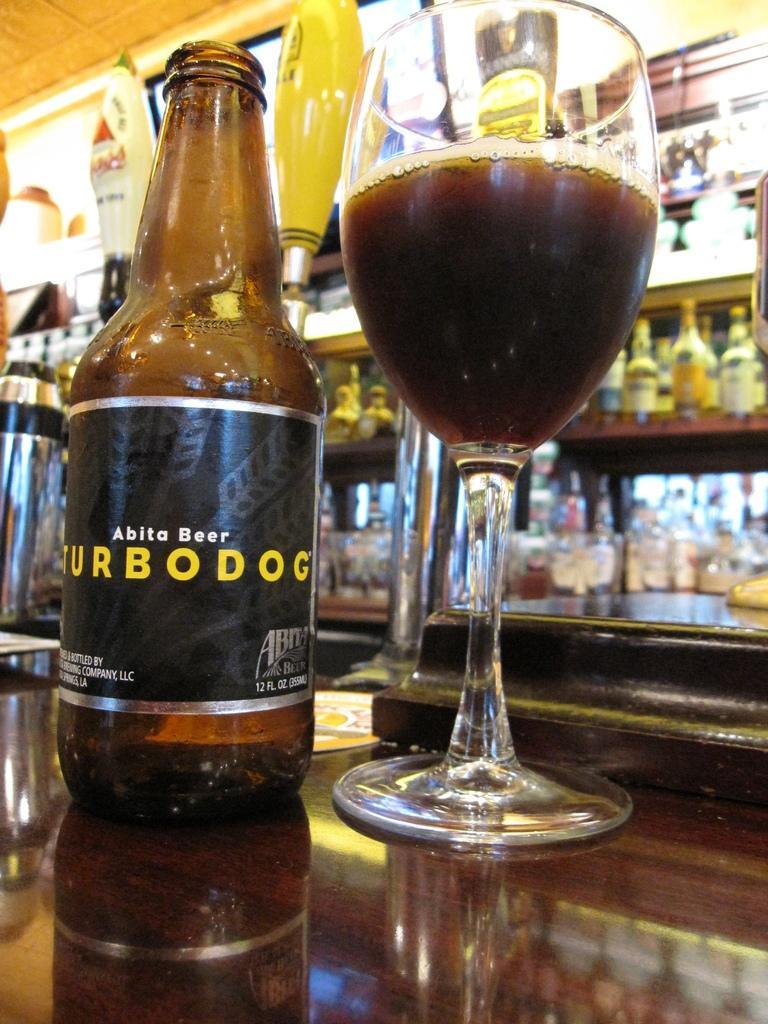Could you give a brief overview of what you see in this image? This is a beer bottle and a wine glass placed on the table. At background I can see bottles placed in the rack,and I can see an yellow color object behind the bottle. 